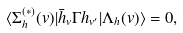Convert formula to latex. <formula><loc_0><loc_0><loc_500><loc_500>\langle \Sigma ^ { ( * ) } _ { h } ( v ) | \bar { h } _ { v } \Gamma h _ { v ^ { \prime } } | \Lambda _ { h } ( v ) \rangle = 0 ,</formula> 